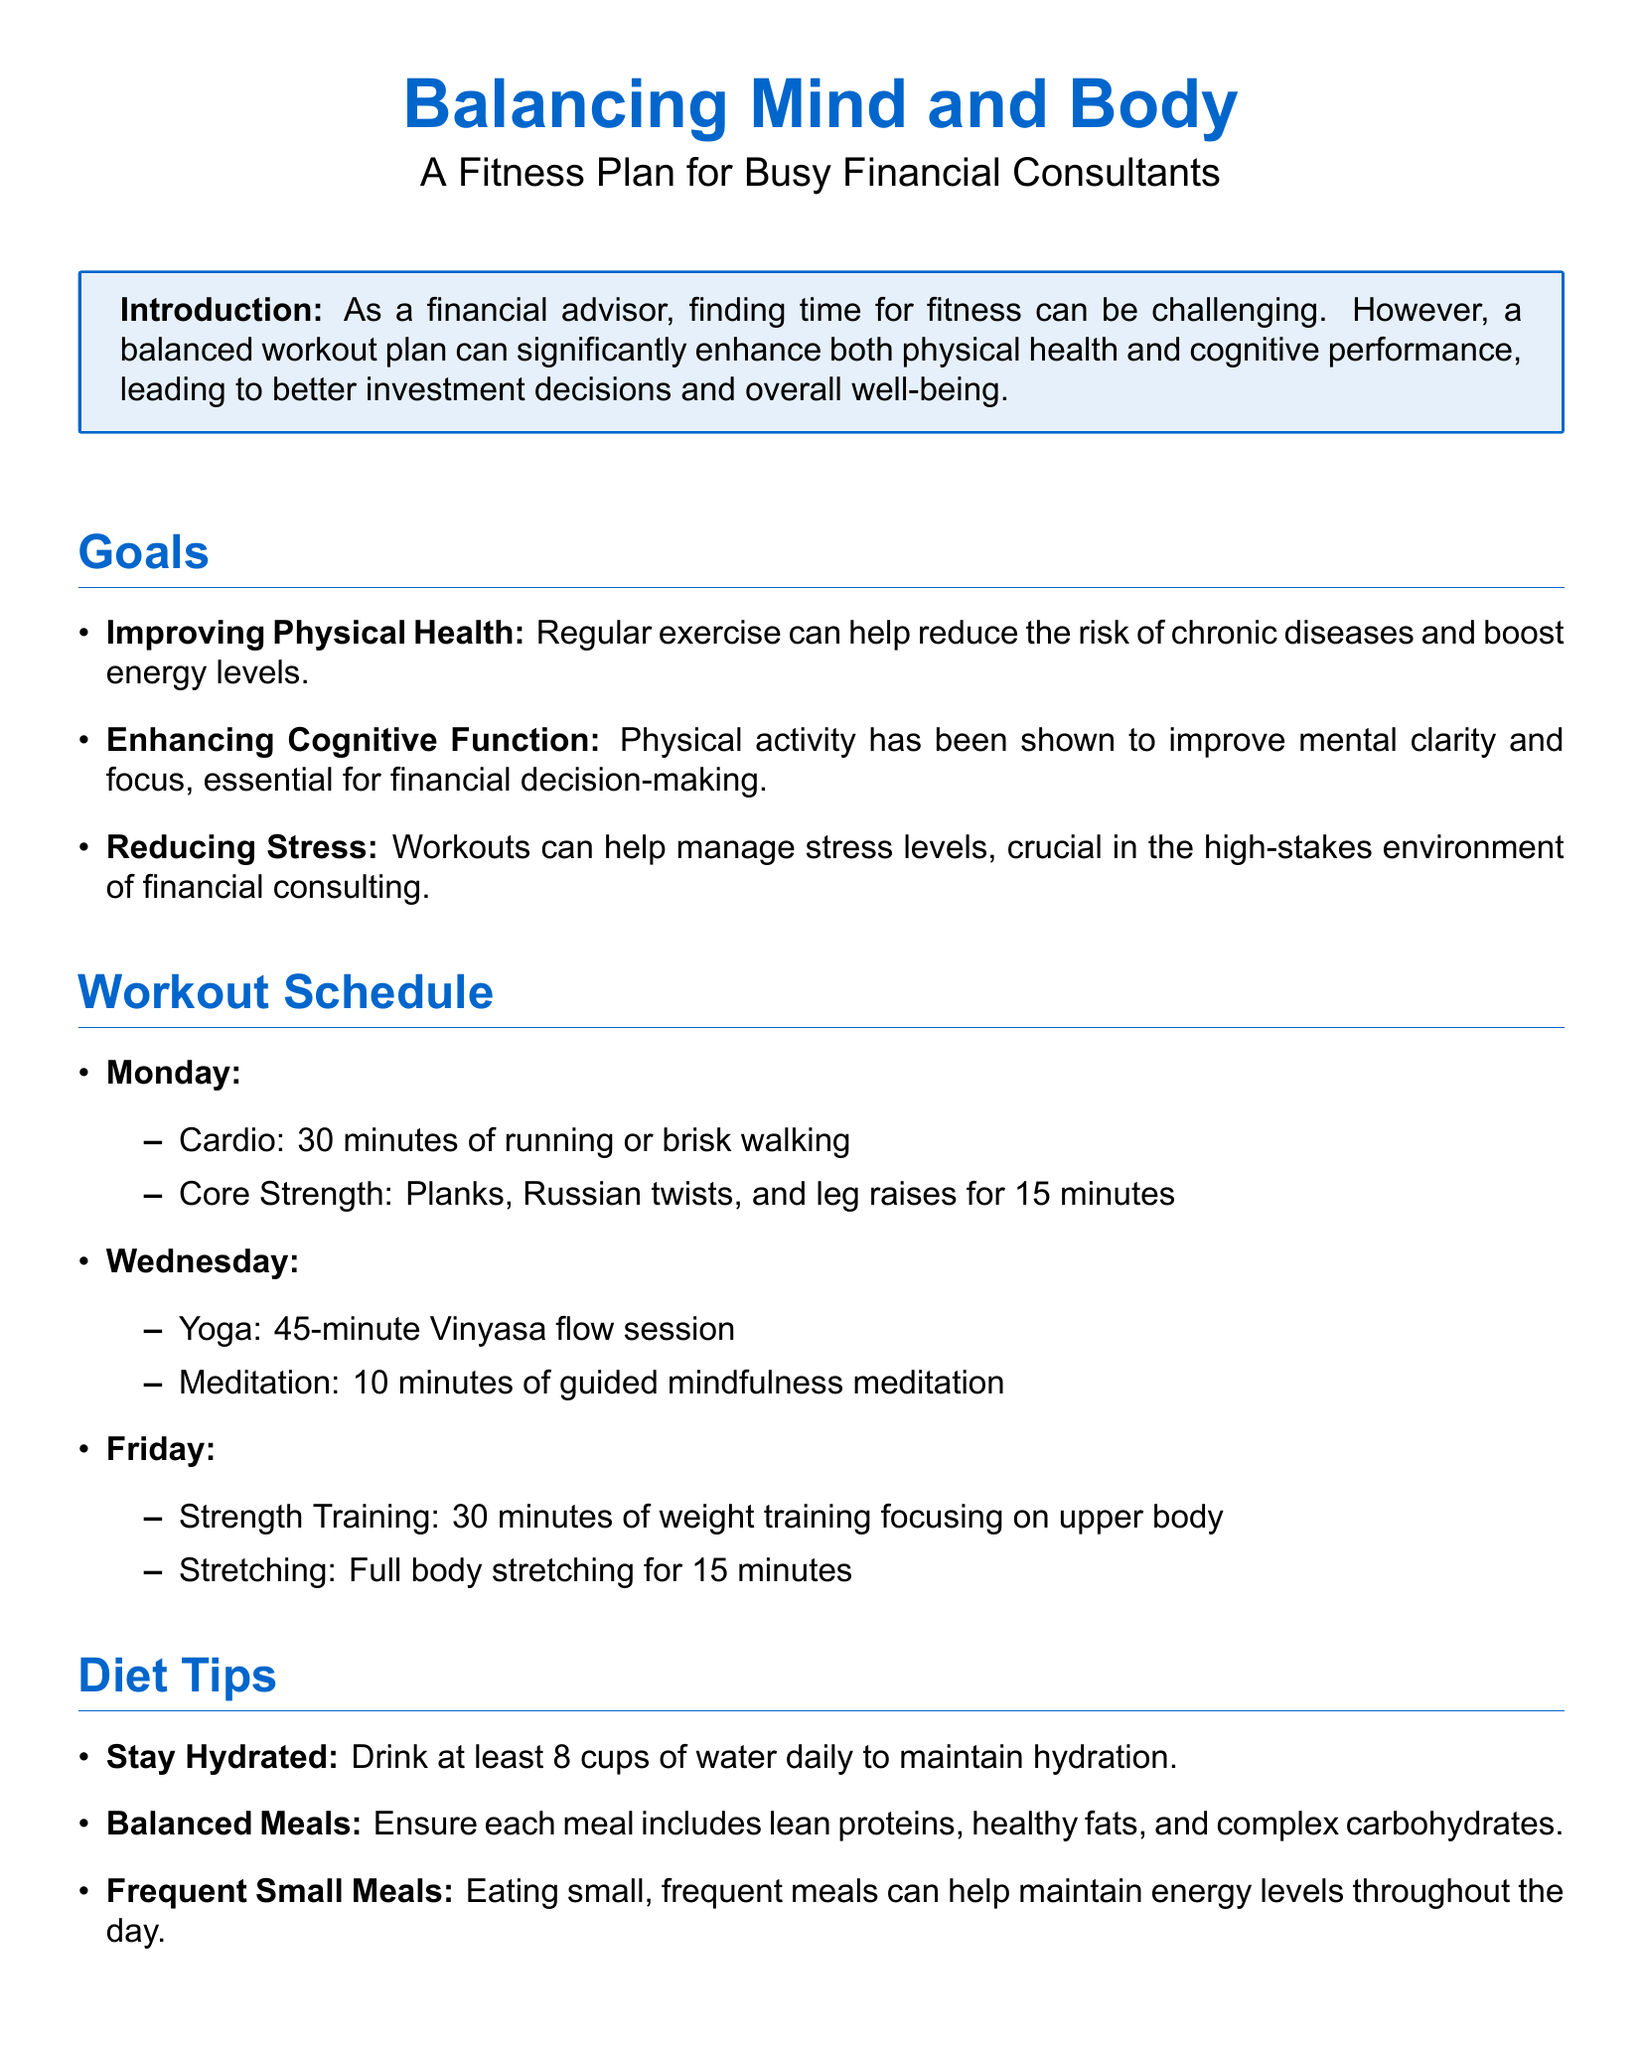What are the main goals of the fitness plan? The goals listed include improving physical health, enhancing cognitive function, and reducing stress.
Answer: Improving physical health, enhancing cognitive function, reducing stress How long is the Vinyasa flow yoga session on Wednesday? The document states that the yoga session is 45 minutes long.
Answer: 45 minutes What type of exercises are included on Monday’s workout schedule? The exercises listed for Monday are cardio and core strength activities.
Answer: Cardio, core strength What should each meal include according to diet tips? The document specifies that each meal should include lean proteins, healthy fats, and complex carbohydrates.
Answer: Lean proteins, healthy fats, complex carbohydrates How many minutes are suggested for meditation on Wednesdays? The document states that 10 minutes of guided mindfulness meditation is recommended.
Answer: 10 minutes What is a recommended frequency for meals? The document suggests eating small, frequent meals to maintain energy levels.
Answer: Small, frequent meals What mindfulness technique involves deep breathing? The mindfulness technique mentioned that involves deep breathing exercises is to practice them for 5 minutes.
Answer: Breathing exercises What type of workout is scheduled for Fridays? The workout scheduled for Fridays consists of strength training focusing on the upper body.
Answer: Strength training 